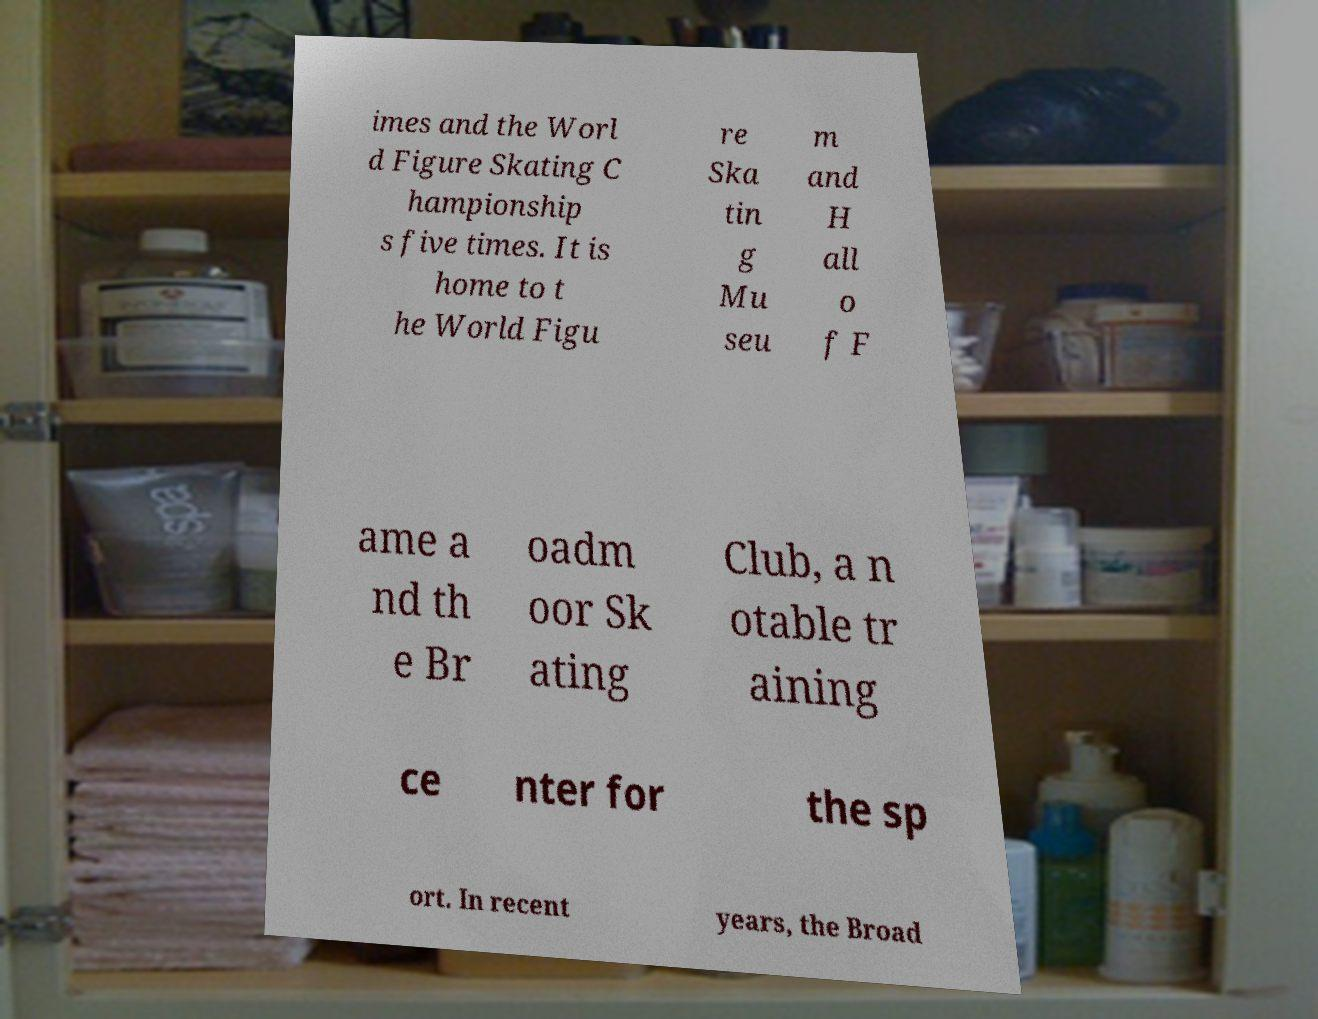I need the written content from this picture converted into text. Can you do that? imes and the Worl d Figure Skating C hampionship s five times. It is home to t he World Figu re Ska tin g Mu seu m and H all o f F ame a nd th e Br oadm oor Sk ating Club, a n otable tr aining ce nter for the sp ort. In recent years, the Broad 